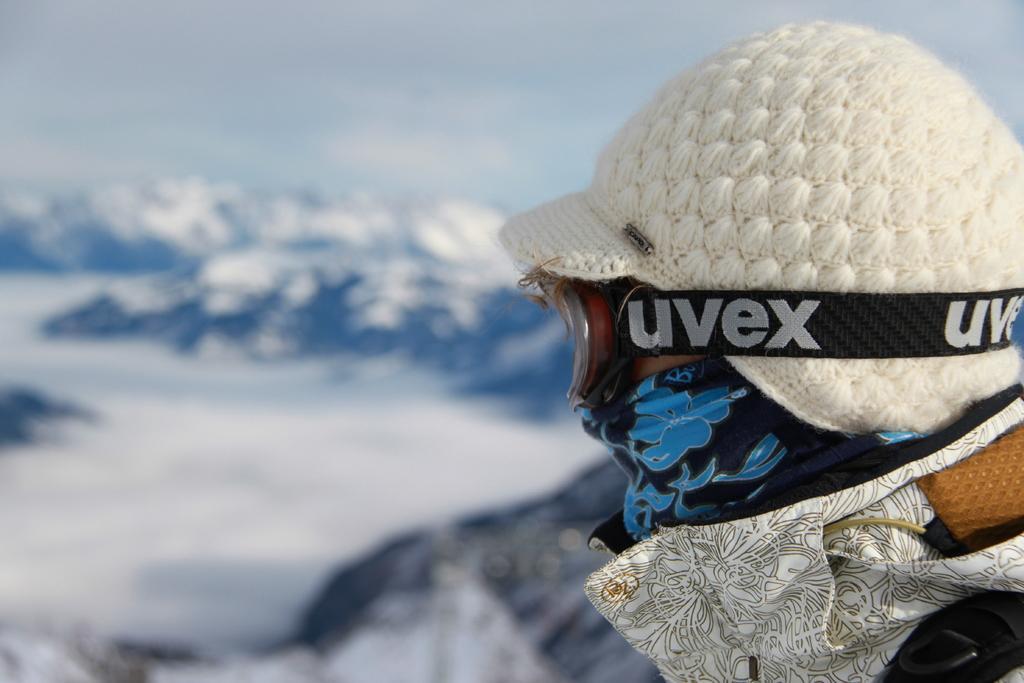In one or two sentences, can you explain what this image depicts? In this picture I can see a human wore a cap and spectacles and I can see hills and a cloudy sky. 